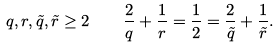Convert formula to latex. <formula><loc_0><loc_0><loc_500><loc_500>q , r , \tilde { q } , \tilde { r } \geq 2 \quad \frac { 2 } { q } + \frac { 1 } { r } = \frac { 1 } { 2 } = \frac { 2 } { \tilde { q } } + \frac { 1 } { \tilde { r } } .</formula> 